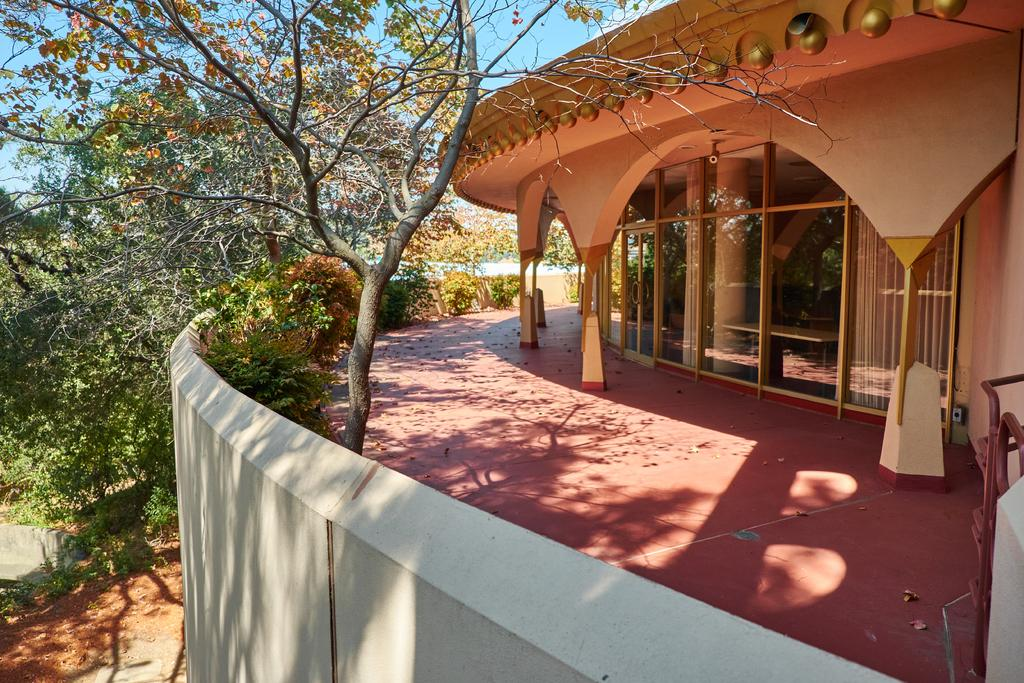What type of structure is present in the image? There is a building in the image. What other natural elements can be seen in the image? There are trees in the image. What can be seen in the distance in the image? The sky is visible in the background of the image. Is there a cable hanging from the building in the image? There is no mention of a cable in the provided facts, so it cannot be determined if one is present in the image. 